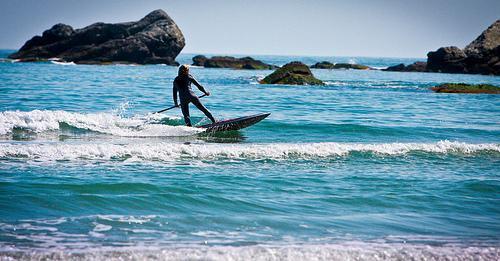How many people are in this photo?
Give a very brief answer. 1. 